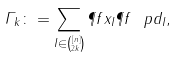Convert formula to latex. <formula><loc_0><loc_0><loc_500><loc_500>\varGamma _ { k } \colon = \sum _ { I \in \binom { [ n ] } { 2 k } } \P f { x _ { I } } \P f { \ p d _ { I } } ,</formula> 